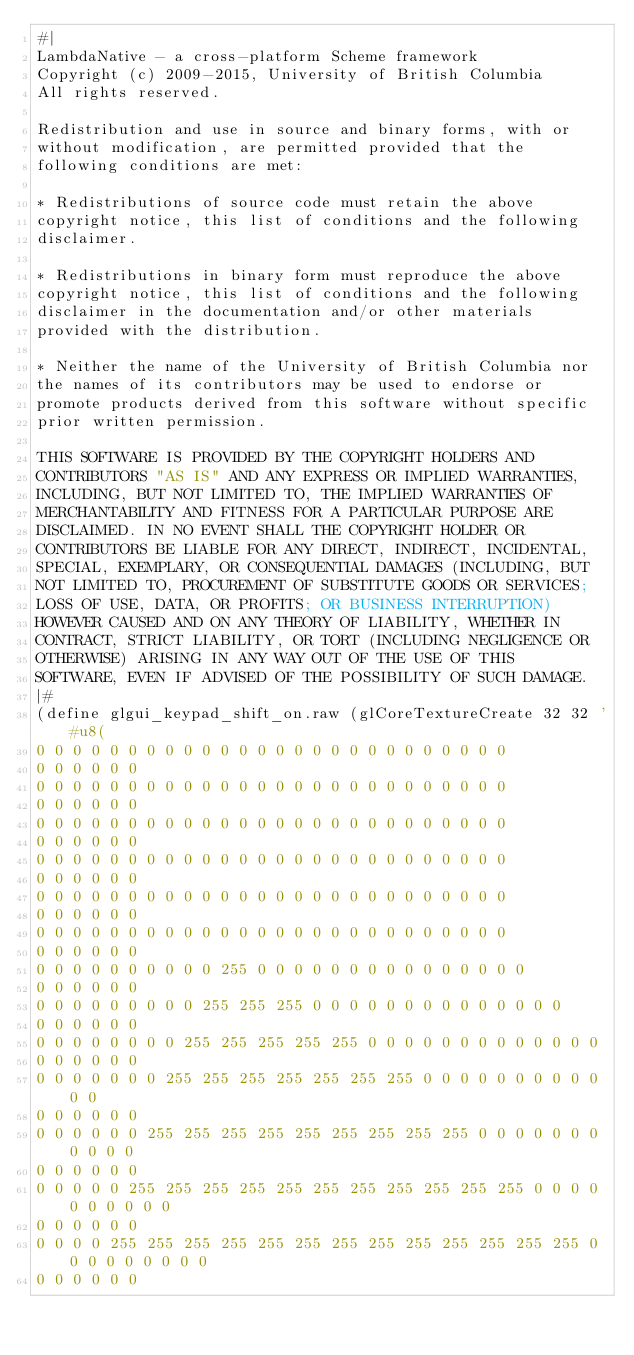<code> <loc_0><loc_0><loc_500><loc_500><_Scheme_>#|
LambdaNative - a cross-platform Scheme framework
Copyright (c) 2009-2015, University of British Columbia
All rights reserved.

Redistribution and use in source and binary forms, with or
without modification, are permitted provided that the
following conditions are met:

* Redistributions of source code must retain the above
copyright notice, this list of conditions and the following
disclaimer.

* Redistributions in binary form must reproduce the above
copyright notice, this list of conditions and the following
disclaimer in the documentation and/or other materials
provided with the distribution.

* Neither the name of the University of British Columbia nor
the names of its contributors may be used to endorse or
promote products derived from this software without specific
prior written permission.

THIS SOFTWARE IS PROVIDED BY THE COPYRIGHT HOLDERS AND
CONTRIBUTORS "AS IS" AND ANY EXPRESS OR IMPLIED WARRANTIES,
INCLUDING, BUT NOT LIMITED TO, THE IMPLIED WARRANTIES OF
MERCHANTABILITY AND FITNESS FOR A PARTICULAR PURPOSE ARE
DISCLAIMED. IN NO EVENT SHALL THE COPYRIGHT HOLDER OR
CONTRIBUTORS BE LIABLE FOR ANY DIRECT, INDIRECT, INCIDENTAL,
SPECIAL, EXEMPLARY, OR CONSEQUENTIAL DAMAGES (INCLUDING, BUT
NOT LIMITED TO, PROCUREMENT OF SUBSTITUTE GOODS OR SERVICES;
LOSS OF USE, DATA, OR PROFITS; OR BUSINESS INTERRUPTION)
HOWEVER CAUSED AND ON ANY THEORY OF LIABILITY, WHETHER IN
CONTRACT, STRICT LIABILITY, OR TORT (INCLUDING NEGLIGENCE OR
OTHERWISE) ARISING IN ANY WAY OUT OF THE USE OF THIS
SOFTWARE, EVEN IF ADVISED OF THE POSSIBILITY OF SUCH DAMAGE.
|#
(define glgui_keypad_shift_on.raw (glCoreTextureCreate 32 32 '#u8(
0 0 0 0 0 0 0 0 0 0 0 0 0 0 0 0 0 0 0 0 0 0 0 0 0 0 
0 0 0 0 0 0 
0 0 0 0 0 0 0 0 0 0 0 0 0 0 0 0 0 0 0 0 0 0 0 0 0 0 
0 0 0 0 0 0 
0 0 0 0 0 0 0 0 0 0 0 0 0 0 0 0 0 0 0 0 0 0 0 0 0 0 
0 0 0 0 0 0 
0 0 0 0 0 0 0 0 0 0 0 0 0 0 0 0 0 0 0 0 0 0 0 0 0 0 
0 0 0 0 0 0 
0 0 0 0 0 0 0 0 0 0 0 0 0 0 0 0 0 0 0 0 0 0 0 0 0 0 
0 0 0 0 0 0 
0 0 0 0 0 0 0 0 0 0 0 0 0 0 0 0 0 0 0 0 0 0 0 0 0 0 
0 0 0 0 0 0 
0 0 0 0 0 0 0 0 0 0 255 0 0 0 0 0 0 0 0 0 0 0 0 0 0 0 
0 0 0 0 0 0 
0 0 0 0 0 0 0 0 0 255 255 255 0 0 0 0 0 0 0 0 0 0 0 0 0 0 
0 0 0 0 0 0 
0 0 0 0 0 0 0 0 255 255 255 255 255 0 0 0 0 0 0 0 0 0 0 0 0 0 
0 0 0 0 0 0 
0 0 0 0 0 0 0 255 255 255 255 255 255 255 0 0 0 0 0 0 0 0 0 0 0 0 
0 0 0 0 0 0 
0 0 0 0 0 0 255 255 255 255 255 255 255 255 255 0 0 0 0 0 0 0 0 0 0 0 
0 0 0 0 0 0 
0 0 0 0 0 255 255 255 255 255 255 255 255 255 255 255 0 0 0 0 0 0 0 0 0 0 
0 0 0 0 0 0 
0 0 0 0 255 255 255 255 255 255 255 255 255 255 255 255 255 0 0 0 0 0 0 0 0 0 
0 0 0 0 0 0 </code> 